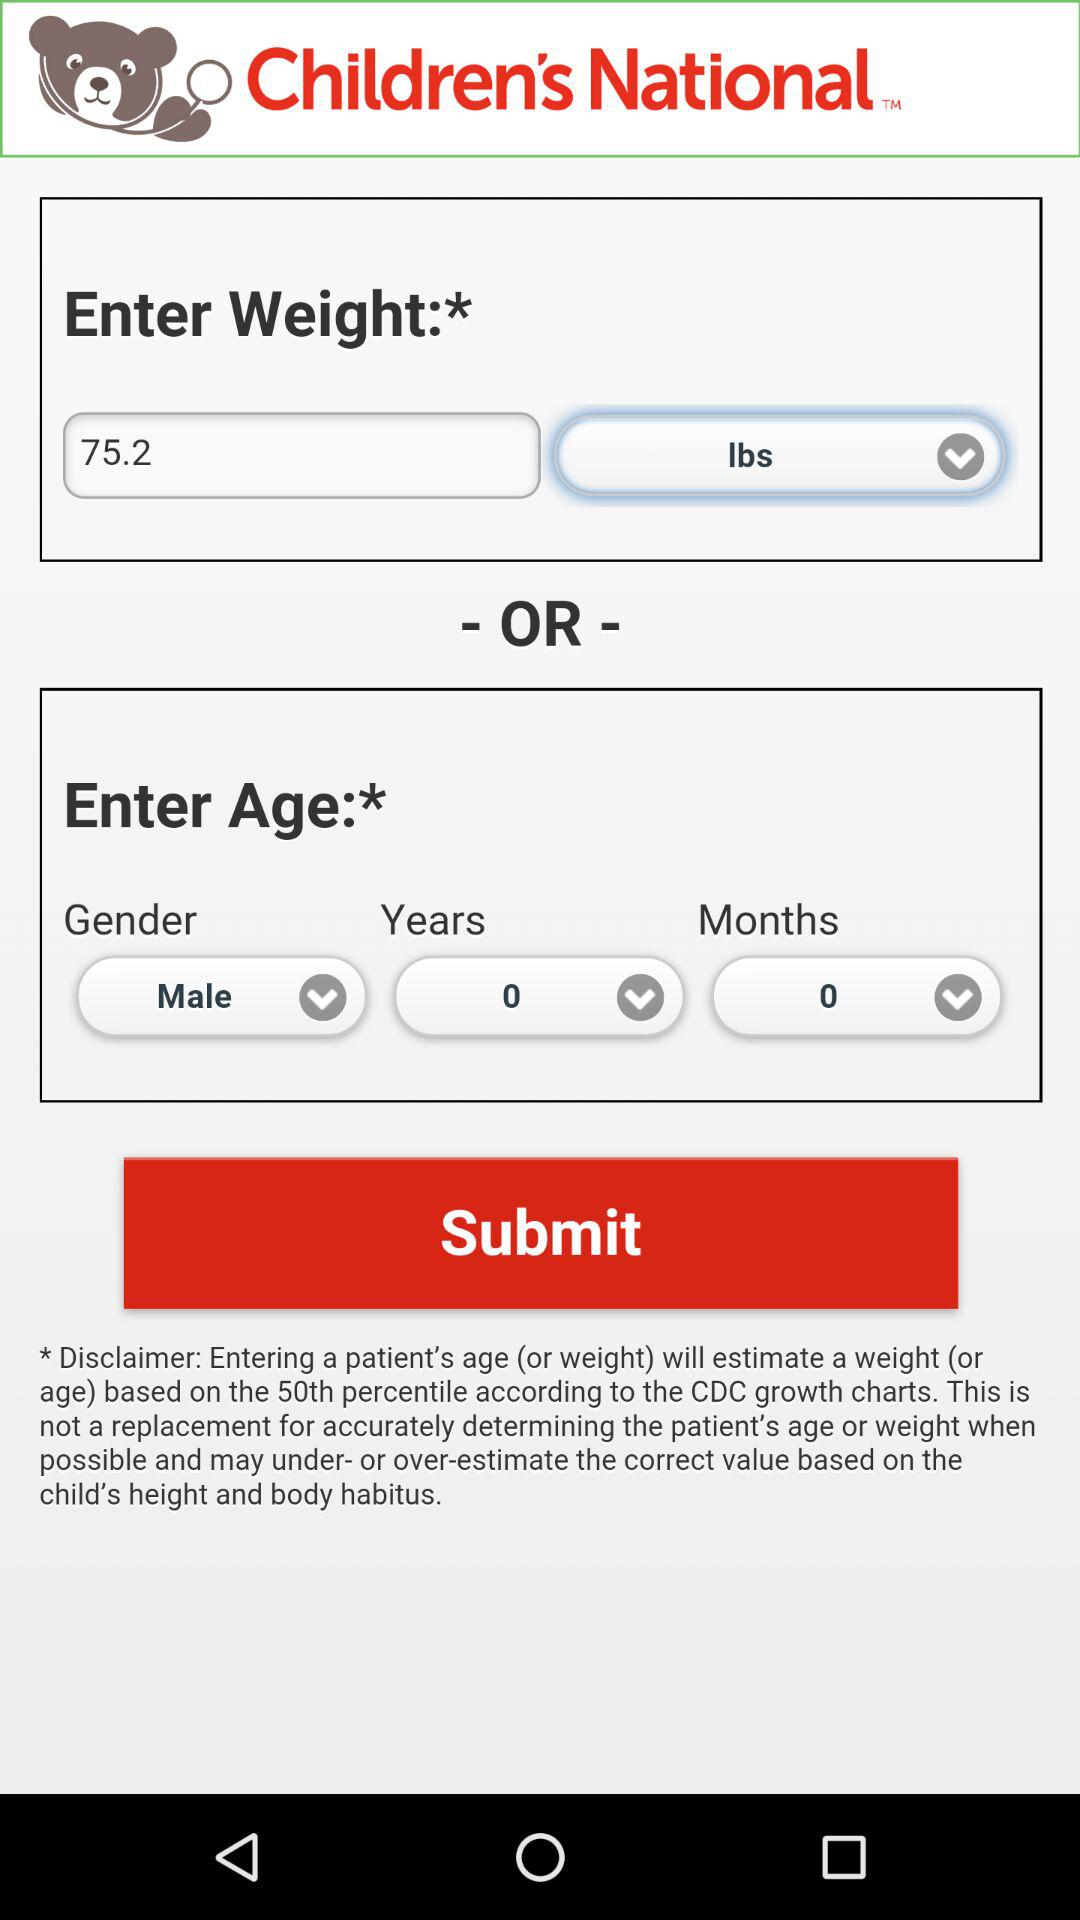What is the application name? The name of the application is "Children's National". 